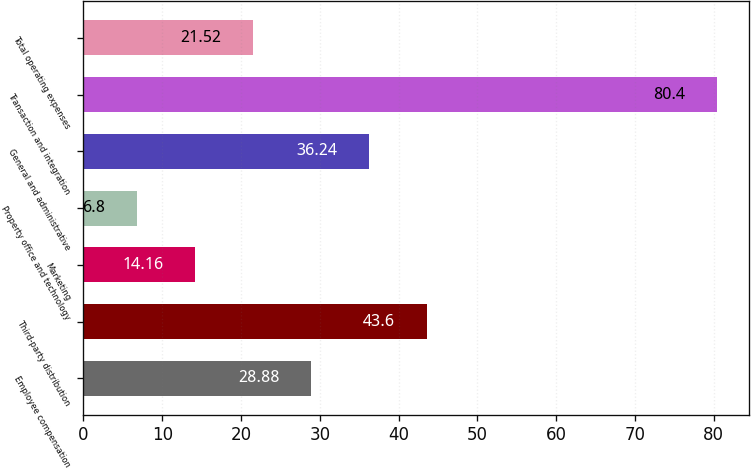Convert chart. <chart><loc_0><loc_0><loc_500><loc_500><bar_chart><fcel>Employee compensation<fcel>Third-party distribution<fcel>Marketing<fcel>Property office and technology<fcel>General and administrative<fcel>Transaction and integration<fcel>Total operating expenses<nl><fcel>28.88<fcel>43.6<fcel>14.16<fcel>6.8<fcel>36.24<fcel>80.4<fcel>21.52<nl></chart> 